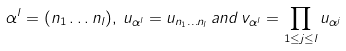Convert formula to latex. <formula><loc_0><loc_0><loc_500><loc_500>\alpha ^ { l } = ( n _ { 1 } \dots n _ { l } ) , \, u _ { \alpha ^ { l } } = u _ { n _ { 1 } \dots n _ { l } } \, a n d \, v _ { \alpha ^ { l } } = \prod _ { 1 \leq j \leq l } u _ { \alpha ^ { j } }</formula> 